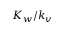Convert formula to latex. <formula><loc_0><loc_0><loc_500><loc_500>K _ { w } / k _ { v }</formula> 